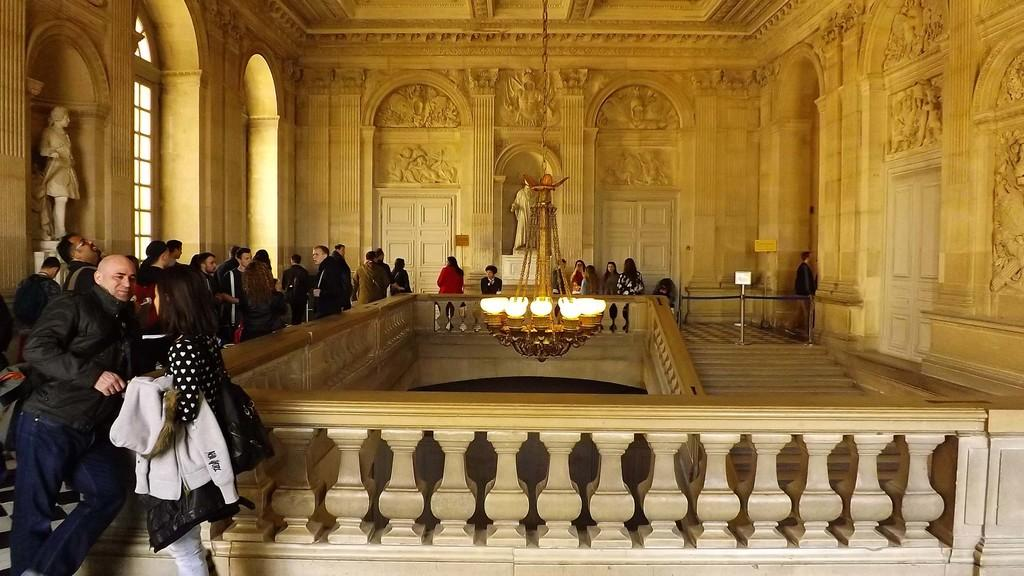What is present in the image that connects or holds things together? There is a chain in the image. What is hanging from the ceiling in the image? There is a chandelier in the image. What provides illumination in the image? There are lights in the image. What structures are present to enclose or separate areas in the image? There are fences and walls with designs in the image. What architectural feature allows for movement between different levels in the image? There are steps in the image. What is used to support or display something in the image? There is a stand in the image. What artistic representations can be seen in the image? There are statues in the image. What allows for natural light to enter the space in the image? There are windows in the image. What provides access to different areas in the image? There are doors in the image. What can be seen on the walls that adds visual interest in the image? There are walls with designs in the image. Who is present in the image? There is a group of people standing in the image. What additional objects can be seen in the image? There are some objects in the image. Where is the cherry tree located in the image? There is no cherry tree present in the image. What type of muscle can be seen flexing in the image? There are no muscles or people flexing in the image. What type of cave is visible in the image? There is no cave present in the image. 